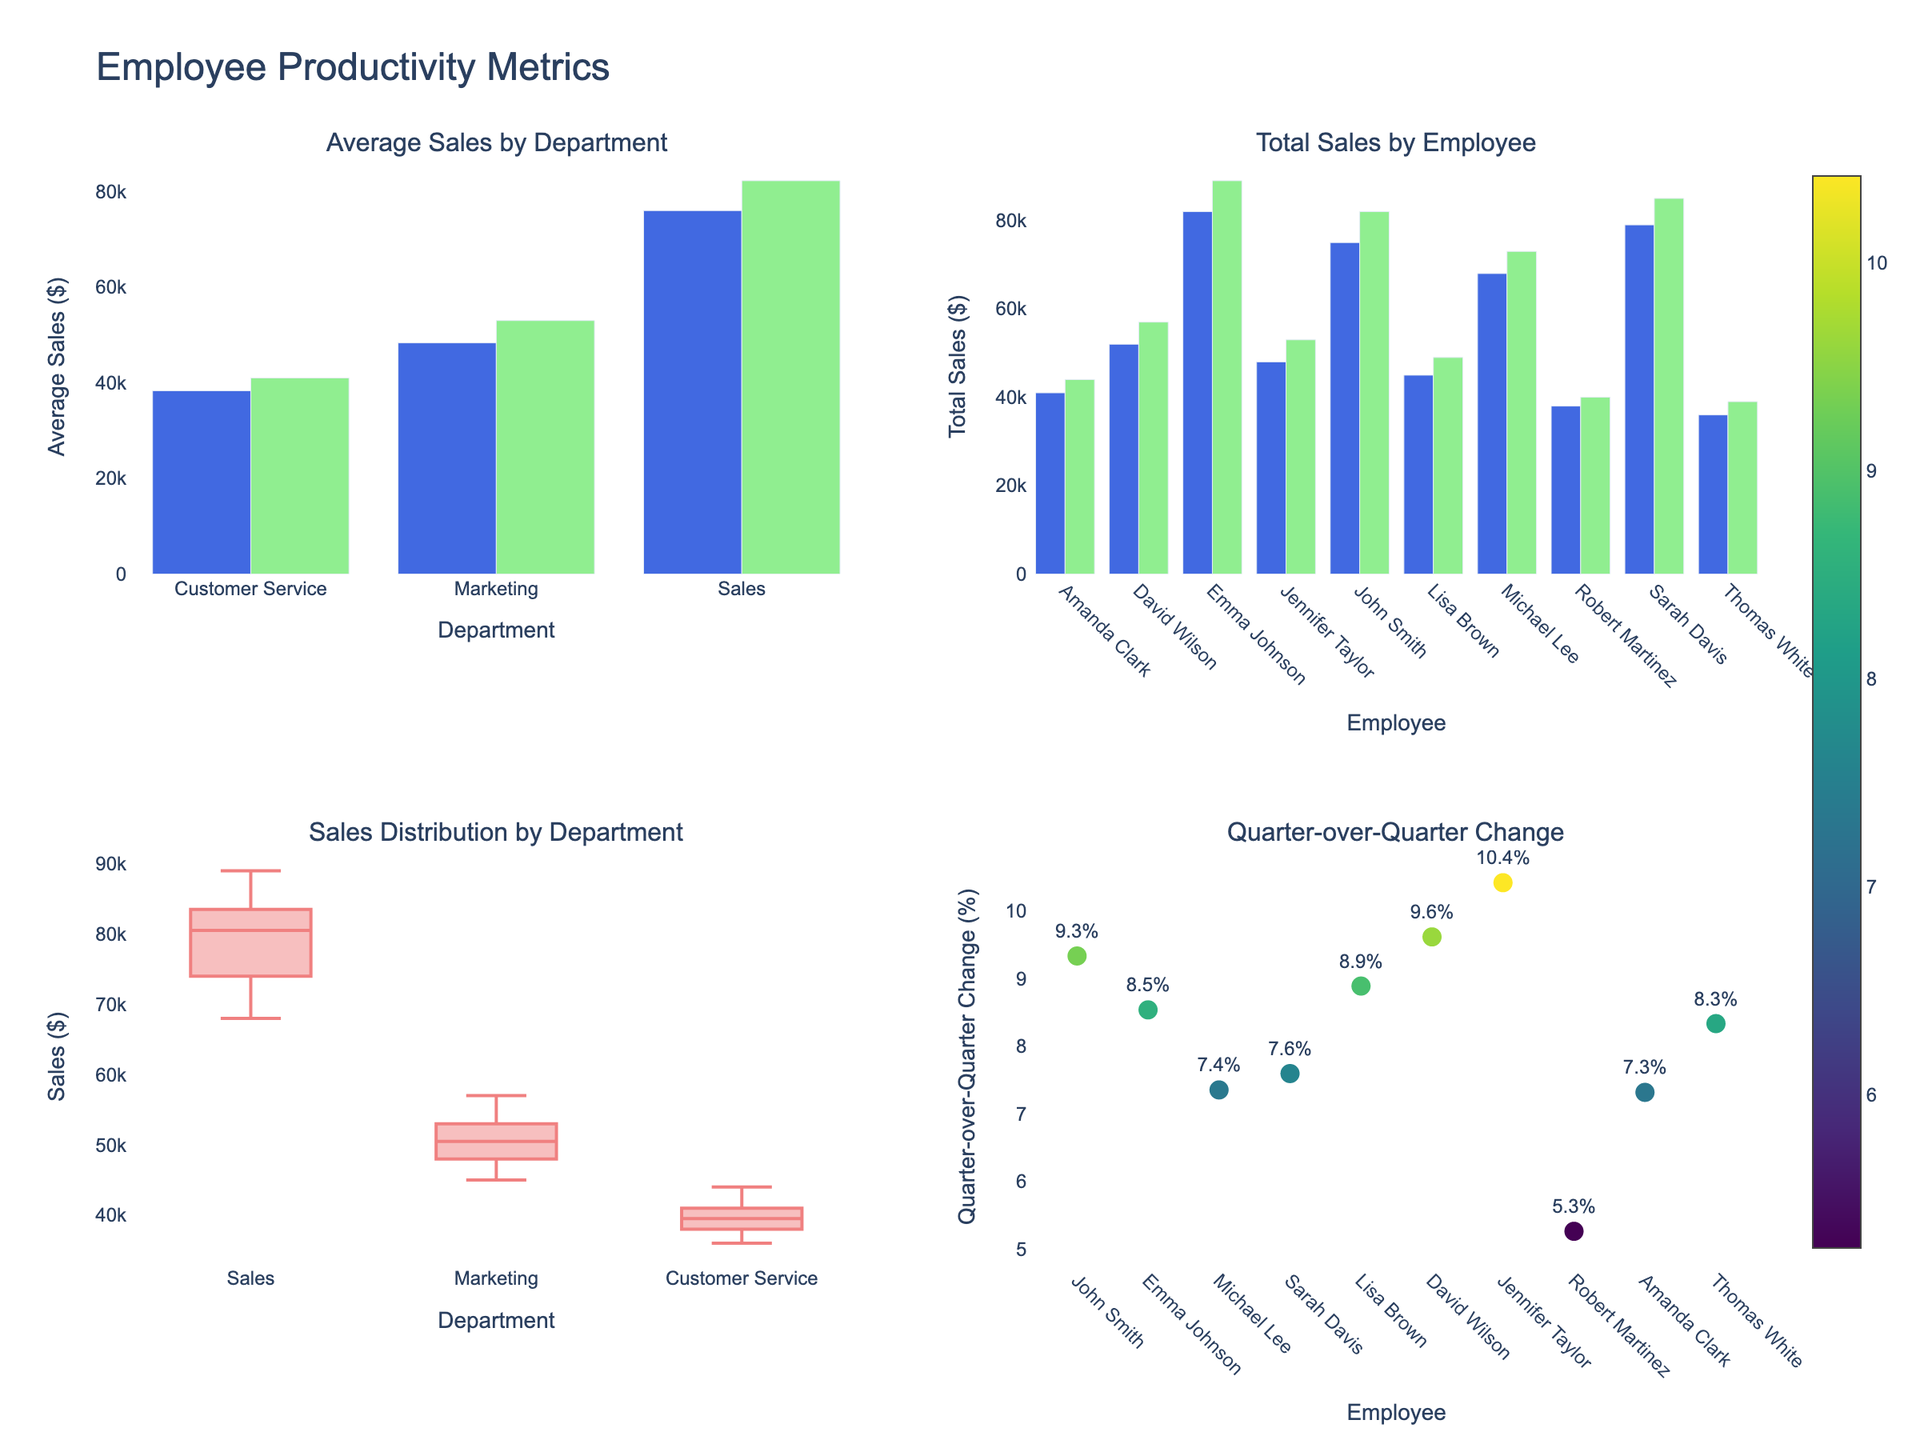What is the title of the figure? The title can be found at the top of the figure. It reads "Employee Productivity Metrics".
Answer: Employee Productivity Metrics What does the x-axis represent in the bar chart on the top left? The x-axis represents different departments. This can be inferred from the "Department" label on the x-axis.
Answer: Departments Which department had the highest average sales in Q1? In the top-left bar chart, compare the heights of the bars for different departments. The Sales department has the highest bar for Q1.
Answer: Sales What is the total sales value for Emma Johnson in Q1 and Q2? In the top-right bar chart, find Emma Johnson's bar heights for both Q1 and Q2 and sum them. Emma Johnson has 82,000 in Q1 and 89,000 in Q2. Summing these gives 82,000 + 89,000 = 171,000.
Answer: 171,000 Which Employee showed the highest percentage change in sales from Q1 to Q2? In the bottom-right scatter plot, look for the marker with the highest percentage value. Emma Johnson has the highest percentage change.
Answer: Emma Johnson How does the average Sales for the Marketing department in Q2 compare to Q1? In the top-left bar chart, compare the heights of the Marketing department's bars. The bar for Q2 is taller than the bar for Q1, indicating higher average sales in Q2.
Answer: Higher in Q2 Which department has the widest range of sales values, according to the box plot in the bottom-left? In the bottom-left box plot, compare the lengths of the boxes and whiskers for each department. The Sales department's box and whiskers span the largest range.
Answer: Sales What is the least performing Employee in Q1 according to total sales? In the top-right bar chart for Q1, find the bar with the smallest height. It corresponds to Thomas White with sales of 36,000.
Answer: Thomas White Which department shows the least variation in sales values in the box plot? In the bottom-left box plot, identify the department with the smallest interquartile range. Customer Service shows the least variation.
Answer: Customer Service 